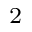Convert formula to latex. <formula><loc_0><loc_0><loc_500><loc_500>^ { 2 }</formula> 